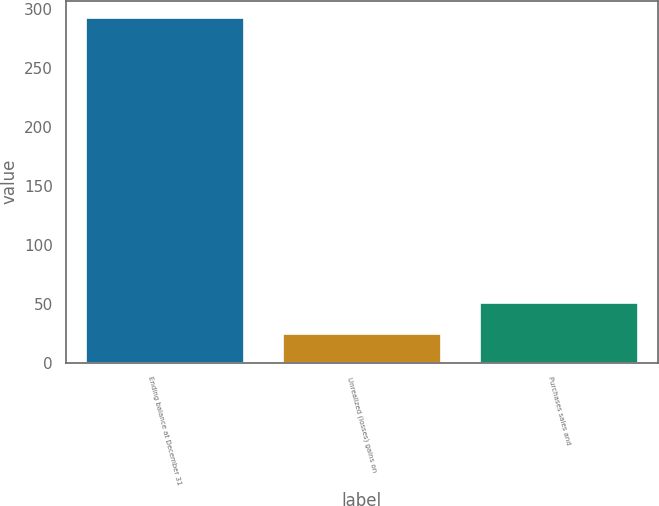<chart> <loc_0><loc_0><loc_500><loc_500><bar_chart><fcel>Ending balance at December 31<fcel>Unrealized (losses) gains on<fcel>Purchases sales and<nl><fcel>292.2<fcel>24<fcel>50.2<nl></chart> 